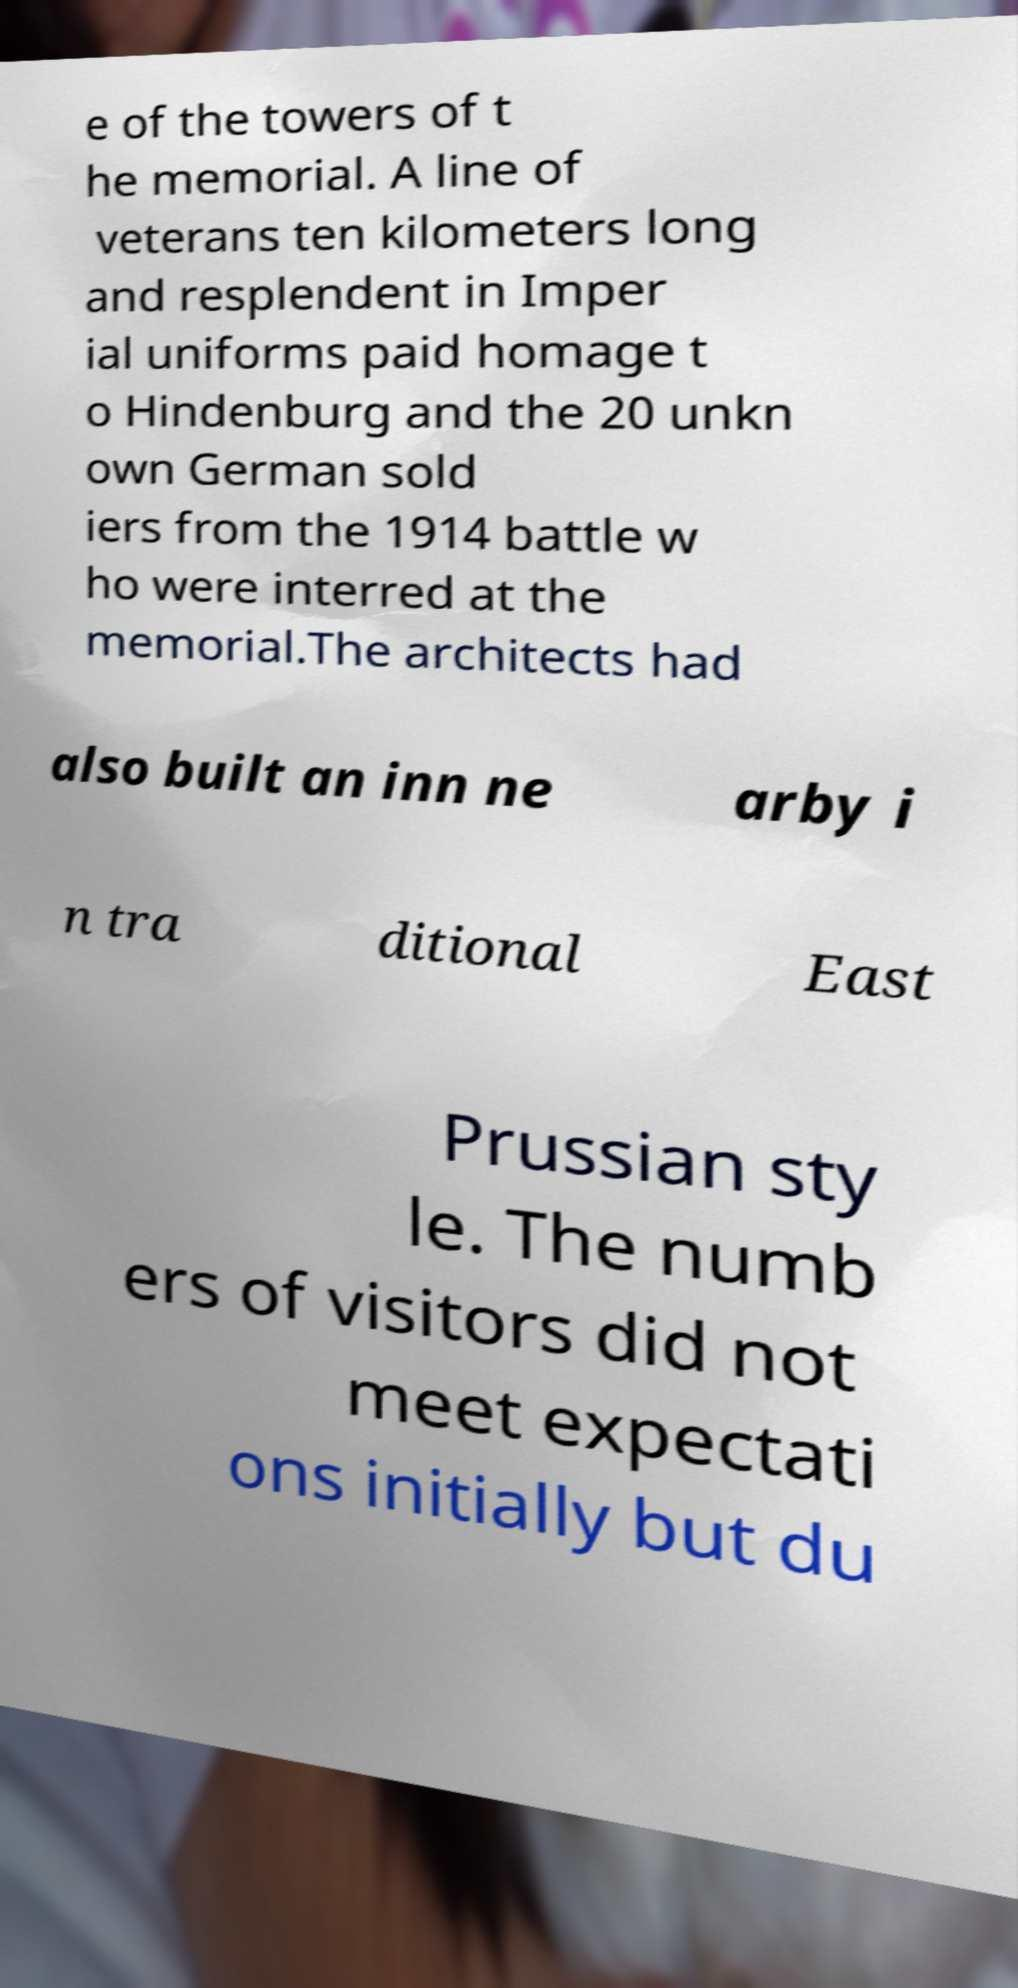Please identify and transcribe the text found in this image. e of the towers of t he memorial. A line of veterans ten kilometers long and resplendent in Imper ial uniforms paid homage t o Hindenburg and the 20 unkn own German sold iers from the 1914 battle w ho were interred at the memorial.The architects had also built an inn ne arby i n tra ditional East Prussian sty le. The numb ers of visitors did not meet expectati ons initially but du 